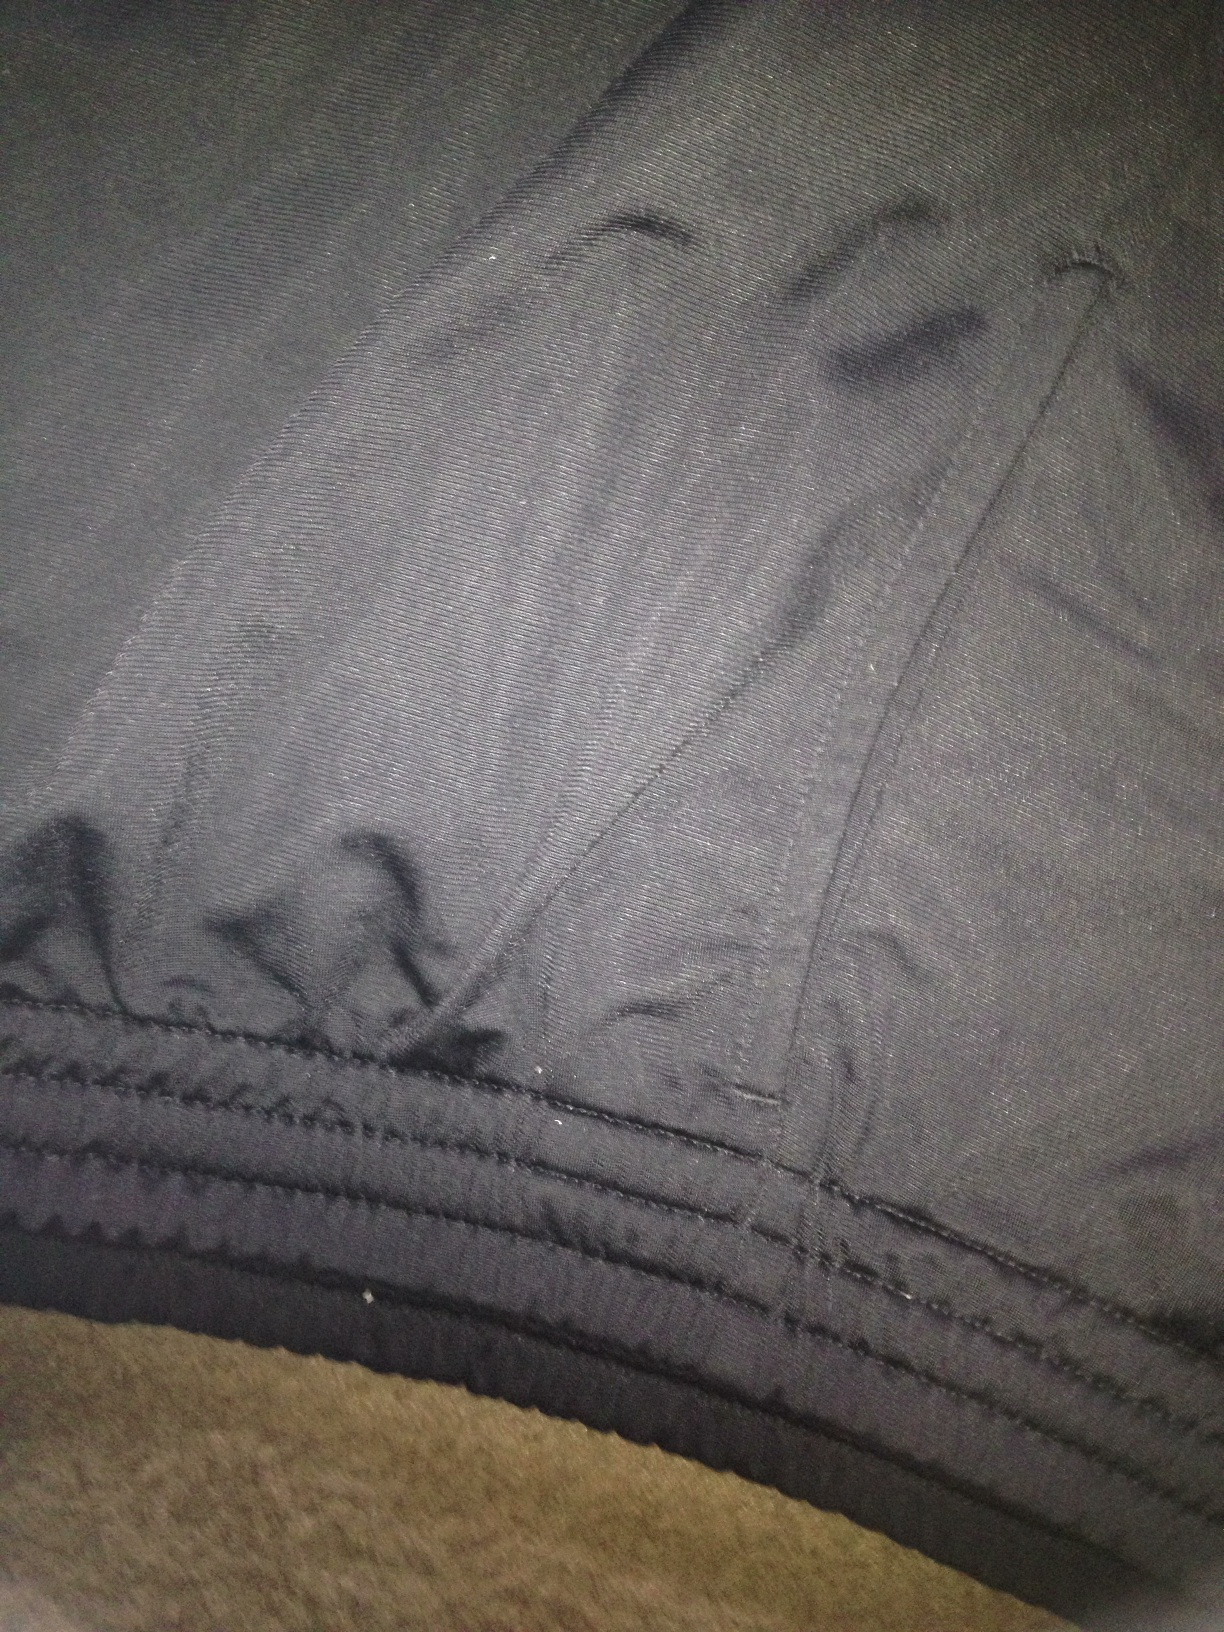What color are these pants? The pants appear to be grey in color. The fabric has a slightly textured pattern which gives it a distinguished look. 